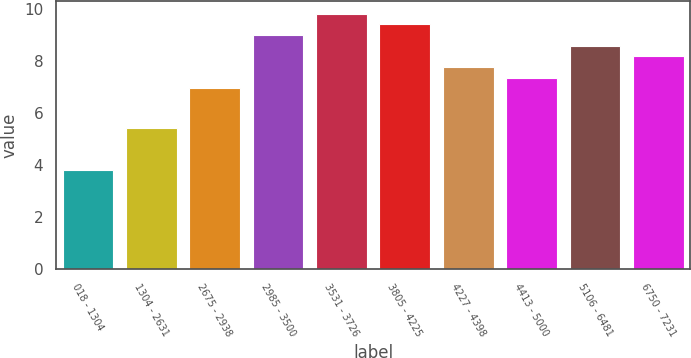<chart> <loc_0><loc_0><loc_500><loc_500><bar_chart><fcel>018 - 1304<fcel>1304 - 2631<fcel>2675 - 2938<fcel>2985 - 3500<fcel>3531 - 3726<fcel>3805 - 4225<fcel>4227 - 4398<fcel>4413 - 5000<fcel>5106 - 6481<fcel>6750 - 7231<nl><fcel>3.81<fcel>5.43<fcel>6.97<fcel>9.02<fcel>9.84<fcel>9.43<fcel>7.79<fcel>7.38<fcel>8.61<fcel>8.2<nl></chart> 